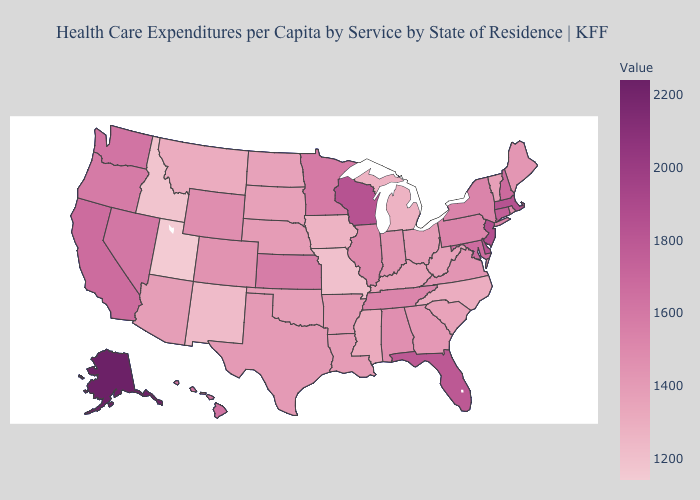Does Florida have a lower value than Nevada?
Give a very brief answer. No. Does Illinois have the lowest value in the USA?
Quick response, please. No. Which states have the lowest value in the USA?
Quick response, please. Utah. Is the legend a continuous bar?
Keep it brief. Yes. Is the legend a continuous bar?
Answer briefly. Yes. Does Alaska have the highest value in the USA?
Short answer required. Yes. Among the states that border Kansas , does Oklahoma have the lowest value?
Quick response, please. No. 